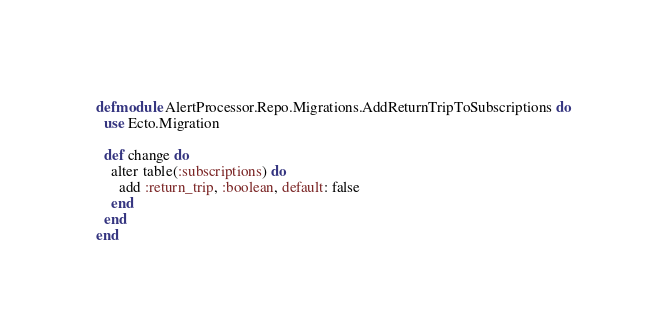Convert code to text. <code><loc_0><loc_0><loc_500><loc_500><_Elixir_>defmodule AlertProcessor.Repo.Migrations.AddReturnTripToSubscriptions do
  use Ecto.Migration

  def change do
    alter table(:subscriptions) do
      add :return_trip, :boolean, default: false
    end
  end
end
</code> 